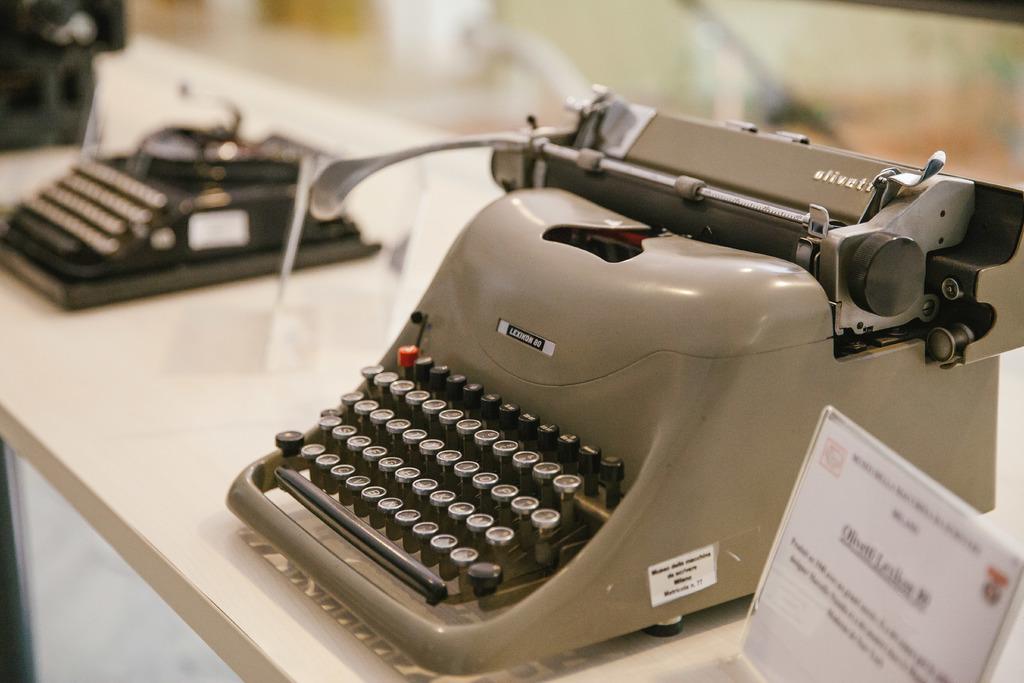What is the brand of the typewriter?
Provide a short and direct response. Lexicon. 